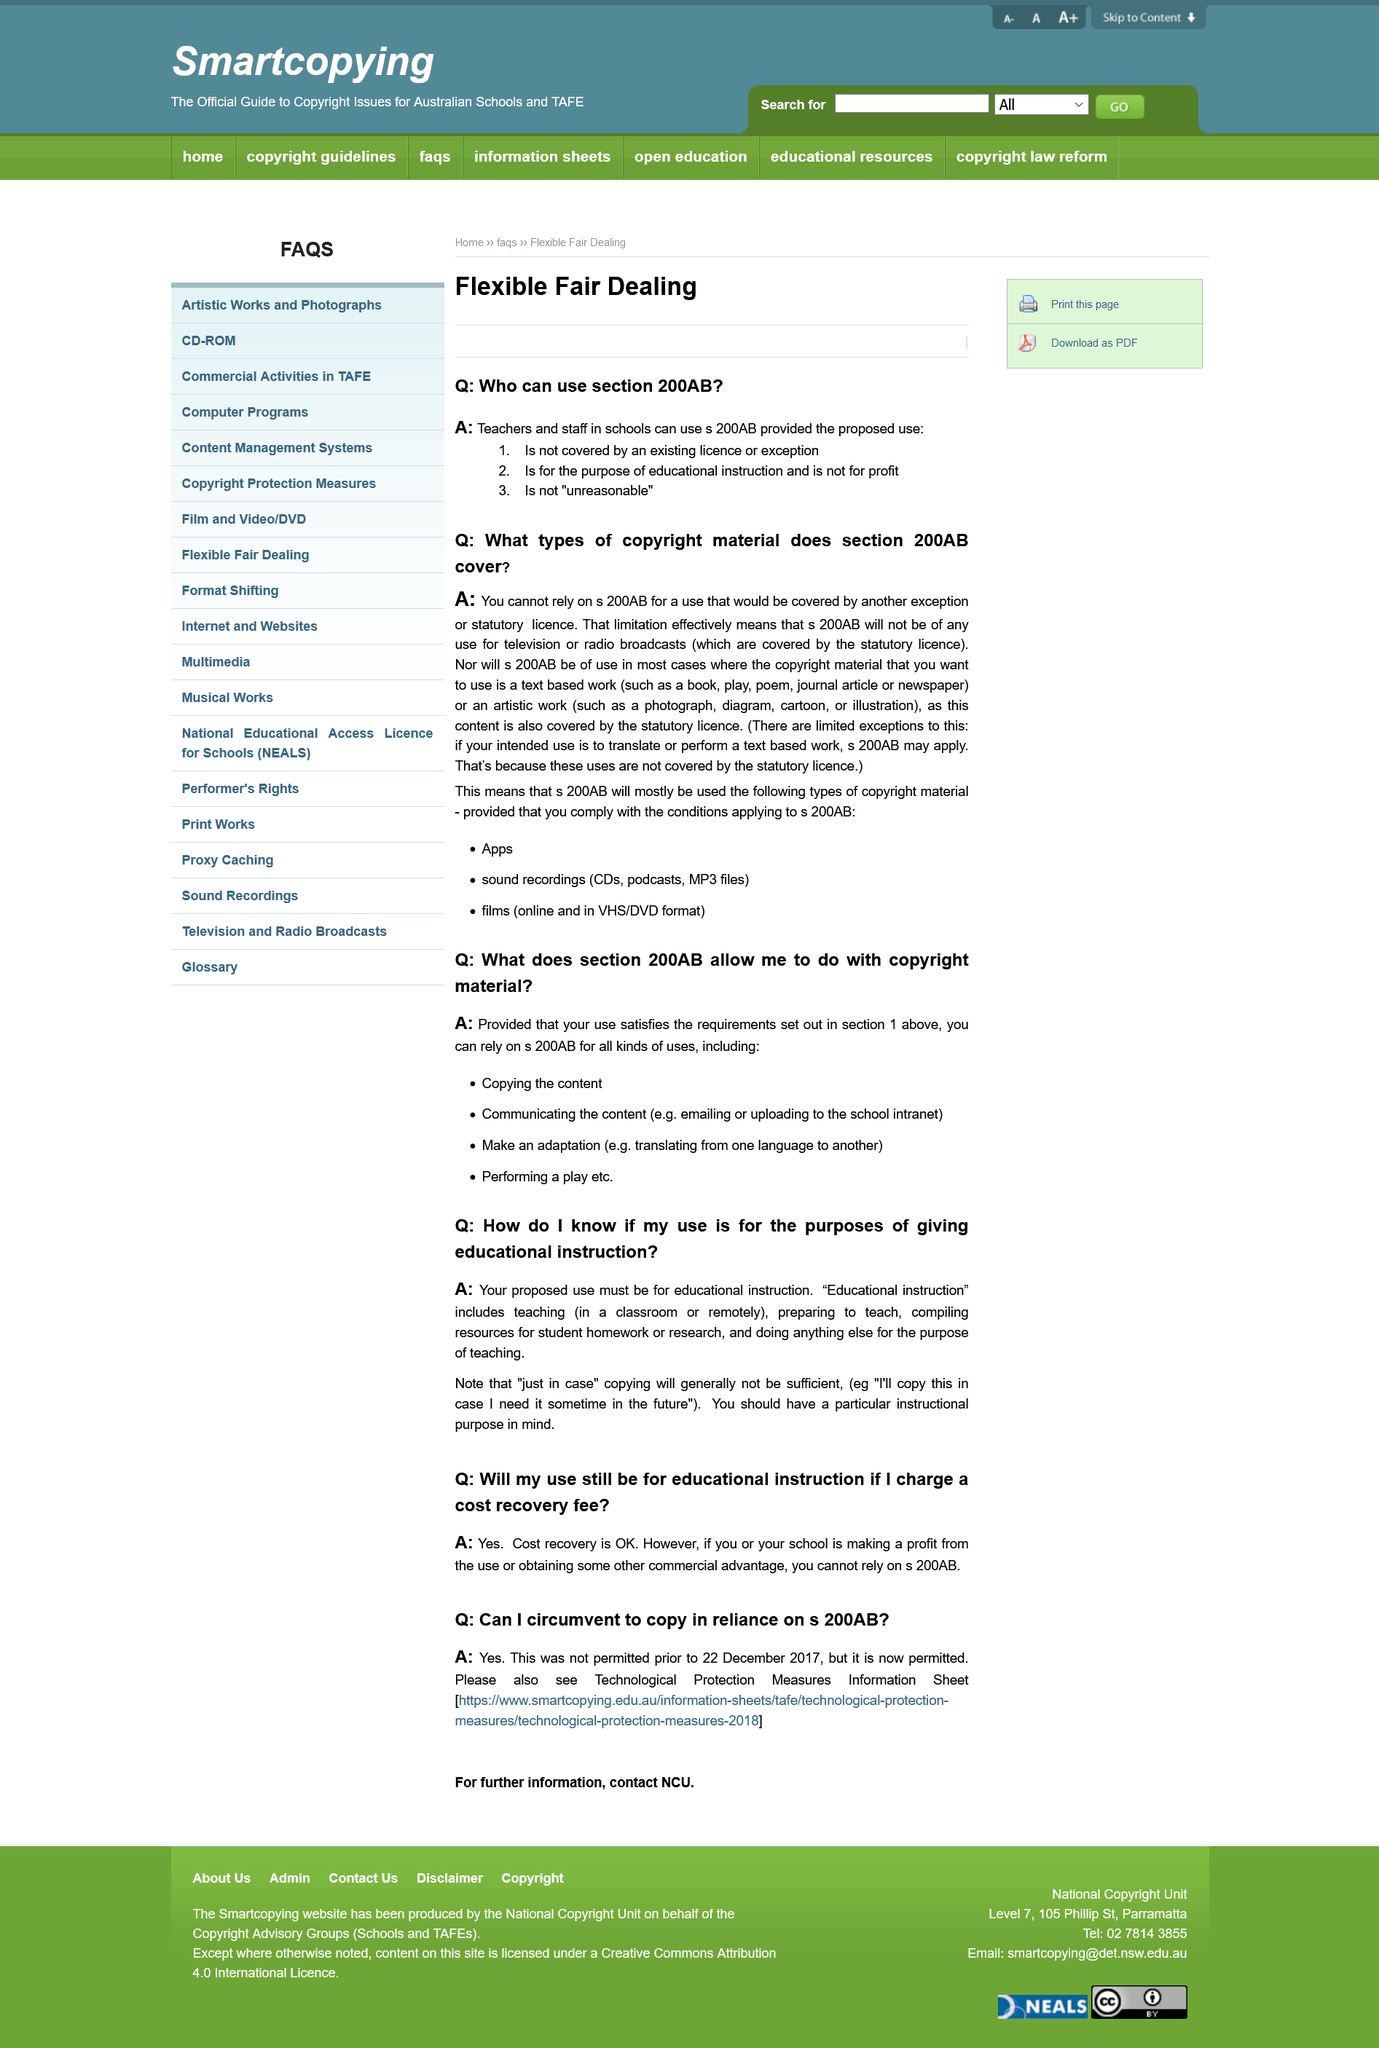Specify some key components in this picture. When can you not rely on the exception for 200AB? You cannot rely on it if the user is covered by another exception or statutory licence. It is acceptable to use copyrighted materials for educational instruction even if you charge a cost recovery fee, as long as the school is not making a profit or obtaining commercial advantage from the use. Educational instruction includes teaching, preparing to teach, compiling resources for student homework or research, and doing anything else for the purpose of teaching. It is imperative that the proposed use be solely for the purpose of educational instruction. It is expected that 200AB will primarily be used for the creation of apps, sound recordings, and films. 